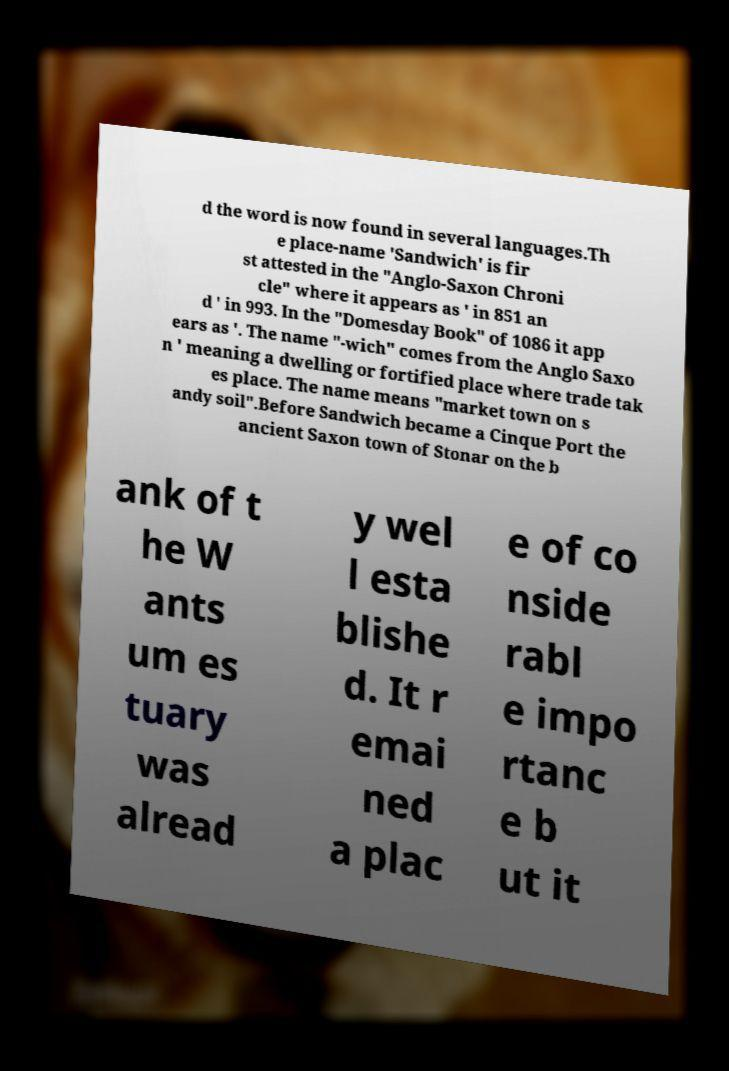Please read and relay the text visible in this image. What does it say? d the word is now found in several languages.Th e place-name 'Sandwich' is fir st attested in the "Anglo-Saxon Chroni cle" where it appears as ' in 851 an d ' in 993. In the "Domesday Book" of 1086 it app ears as '. The name "-wich" comes from the Anglo Saxo n ' meaning a dwelling or fortified place where trade tak es place. The name means "market town on s andy soil".Before Sandwich became a Cinque Port the ancient Saxon town of Stonar on the b ank of t he W ants um es tuary was alread y wel l esta blishe d. It r emai ned a plac e of co nside rabl e impo rtanc e b ut it 